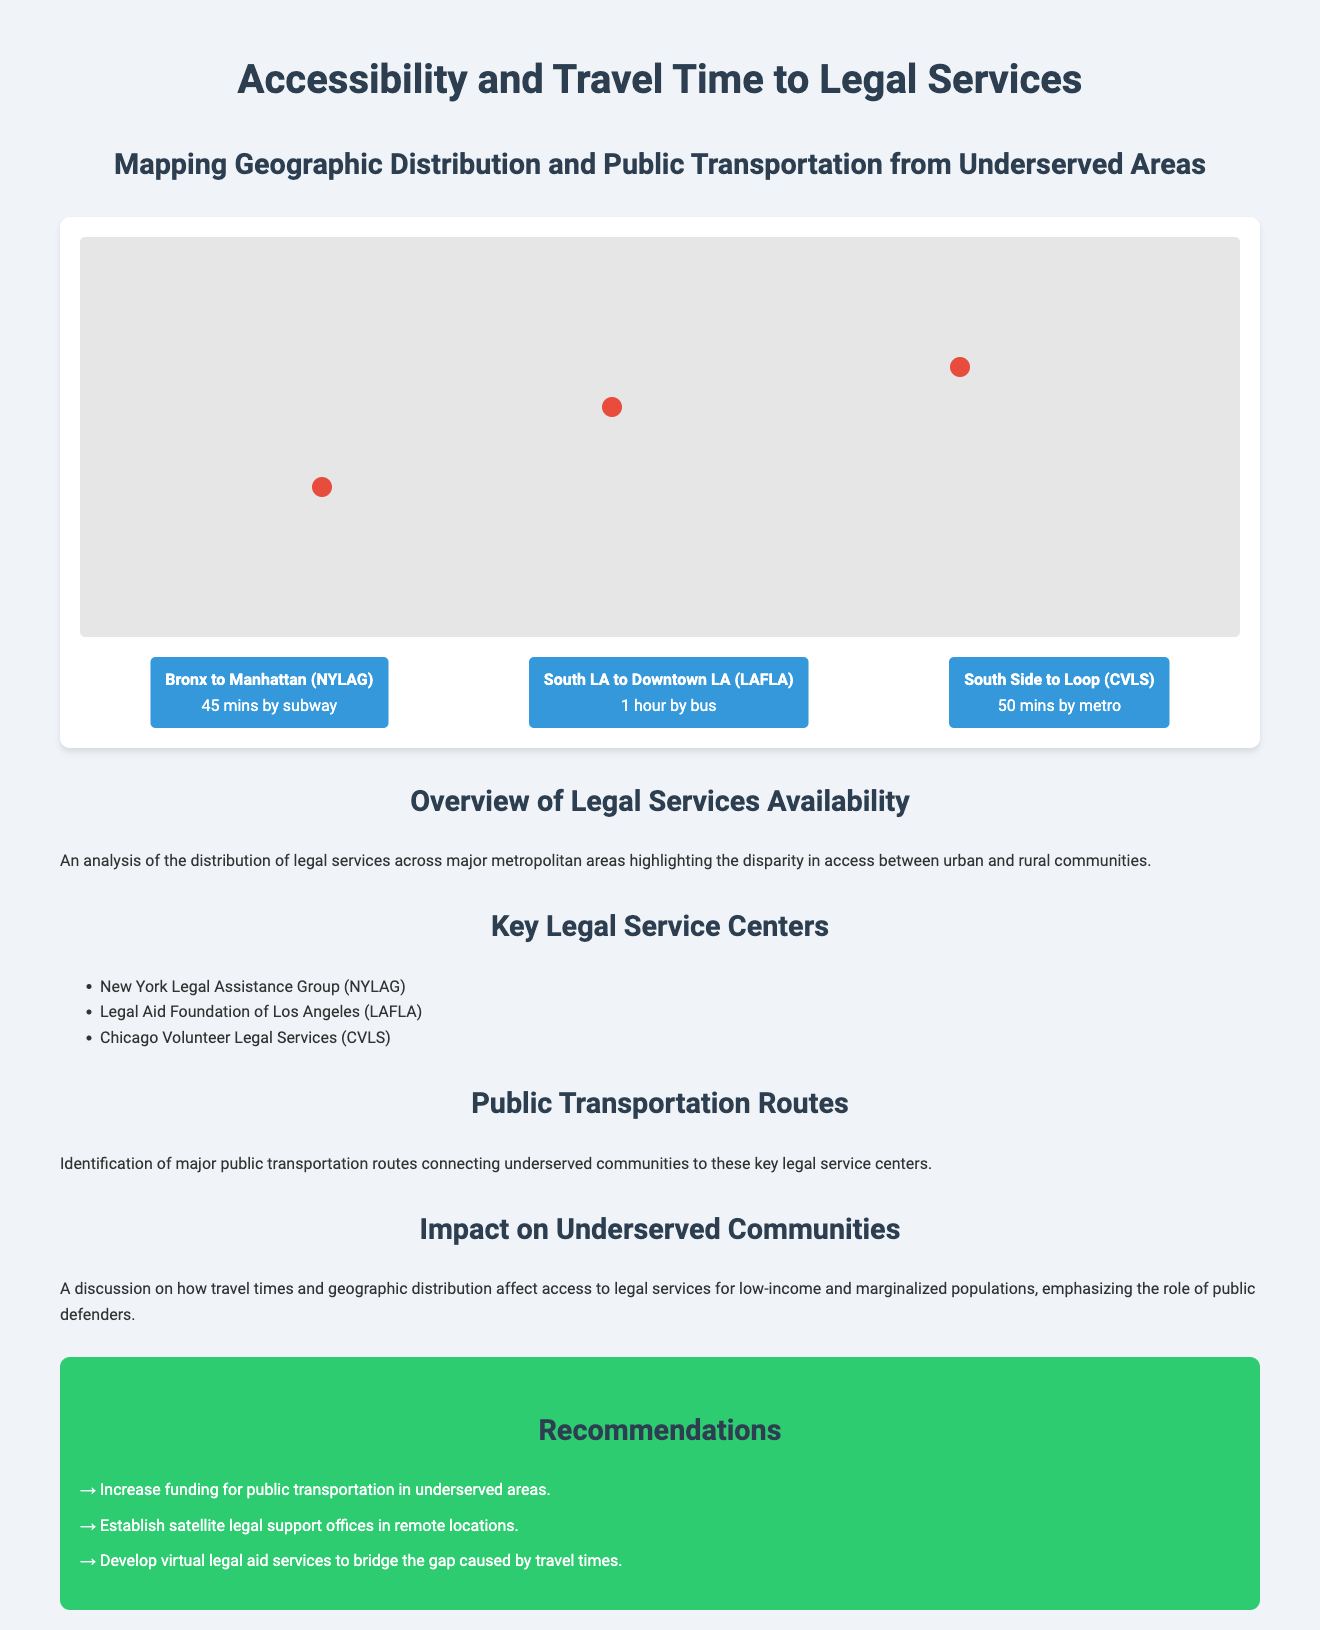What is the title of the document? The title of the document provides the primary subject matter regarding accessibility and travel time, which is "Accessibility and Travel Time to Legal Services."
Answer: Accessibility and Travel Time to Legal Services What is the first legal service center listed? The document provides a list of legal service centers with the first one mentioned being "New York Legal Assistance Group (NYLAG)."
Answer: New York Legal Assistance Group (NYLAG) How long does it take to travel from the Bronx to Manhattan? The travel time from the Bronx to Manhattan is specified in the document as taking 45 minutes by subway.
Answer: 45 mins by subway What recommendation suggests improving access to legal services? The document includes several recommendations, one of which is to "Increase funding for public transportation in underserved areas."
Answer: Increase funding for public transportation in underserved areas What is the average travel time from South LA to Downtown LA? The document states that the travel time from South LA to Downtown LA is 1 hour by bus.
Answer: 1 hour by bus Which legal service is located in Chicago? The Chicago-based legal service center mentioned in the document is "Chicago Volunteer Legal Services (CVLS)."
Answer: Chicago Volunteer Legal Services (CVLS) What is a key issue discussed in relation to underserved communities? The document mentions how "travel times and geographic distribution affect access to legal services" for low-income populations.
Answer: Impact on access to legal services 